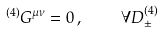Convert formula to latex. <formula><loc_0><loc_0><loc_500><loc_500>^ { ( 4 ) } G ^ { \mu \nu } = 0 \, , \quad \forall D ^ { ( 4 ) } _ { \pm }</formula> 